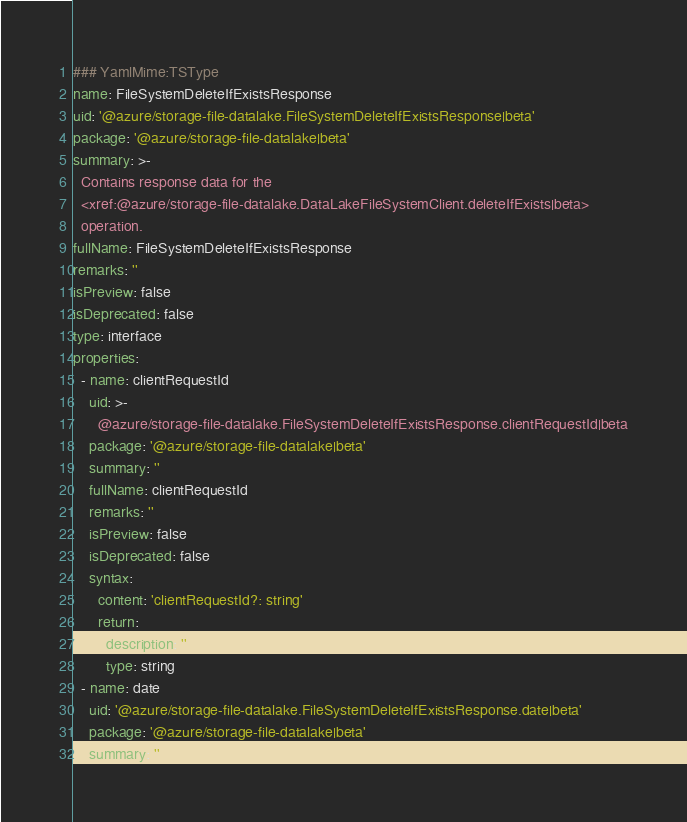<code> <loc_0><loc_0><loc_500><loc_500><_YAML_>### YamlMime:TSType
name: FileSystemDeleteIfExistsResponse
uid: '@azure/storage-file-datalake.FileSystemDeleteIfExistsResponse|beta'
package: '@azure/storage-file-datalake|beta'
summary: >-
  Contains response data for the
  <xref:@azure/storage-file-datalake.DataLakeFileSystemClient.deleteIfExists|beta>
  operation.
fullName: FileSystemDeleteIfExistsResponse
remarks: ''
isPreview: false
isDeprecated: false
type: interface
properties:
  - name: clientRequestId
    uid: >-
      @azure/storage-file-datalake.FileSystemDeleteIfExistsResponse.clientRequestId|beta
    package: '@azure/storage-file-datalake|beta'
    summary: ''
    fullName: clientRequestId
    remarks: ''
    isPreview: false
    isDeprecated: false
    syntax:
      content: 'clientRequestId?: string'
      return:
        description: ''
        type: string
  - name: date
    uid: '@azure/storage-file-datalake.FileSystemDeleteIfExistsResponse.date|beta'
    package: '@azure/storage-file-datalake|beta'
    summary: ''</code> 